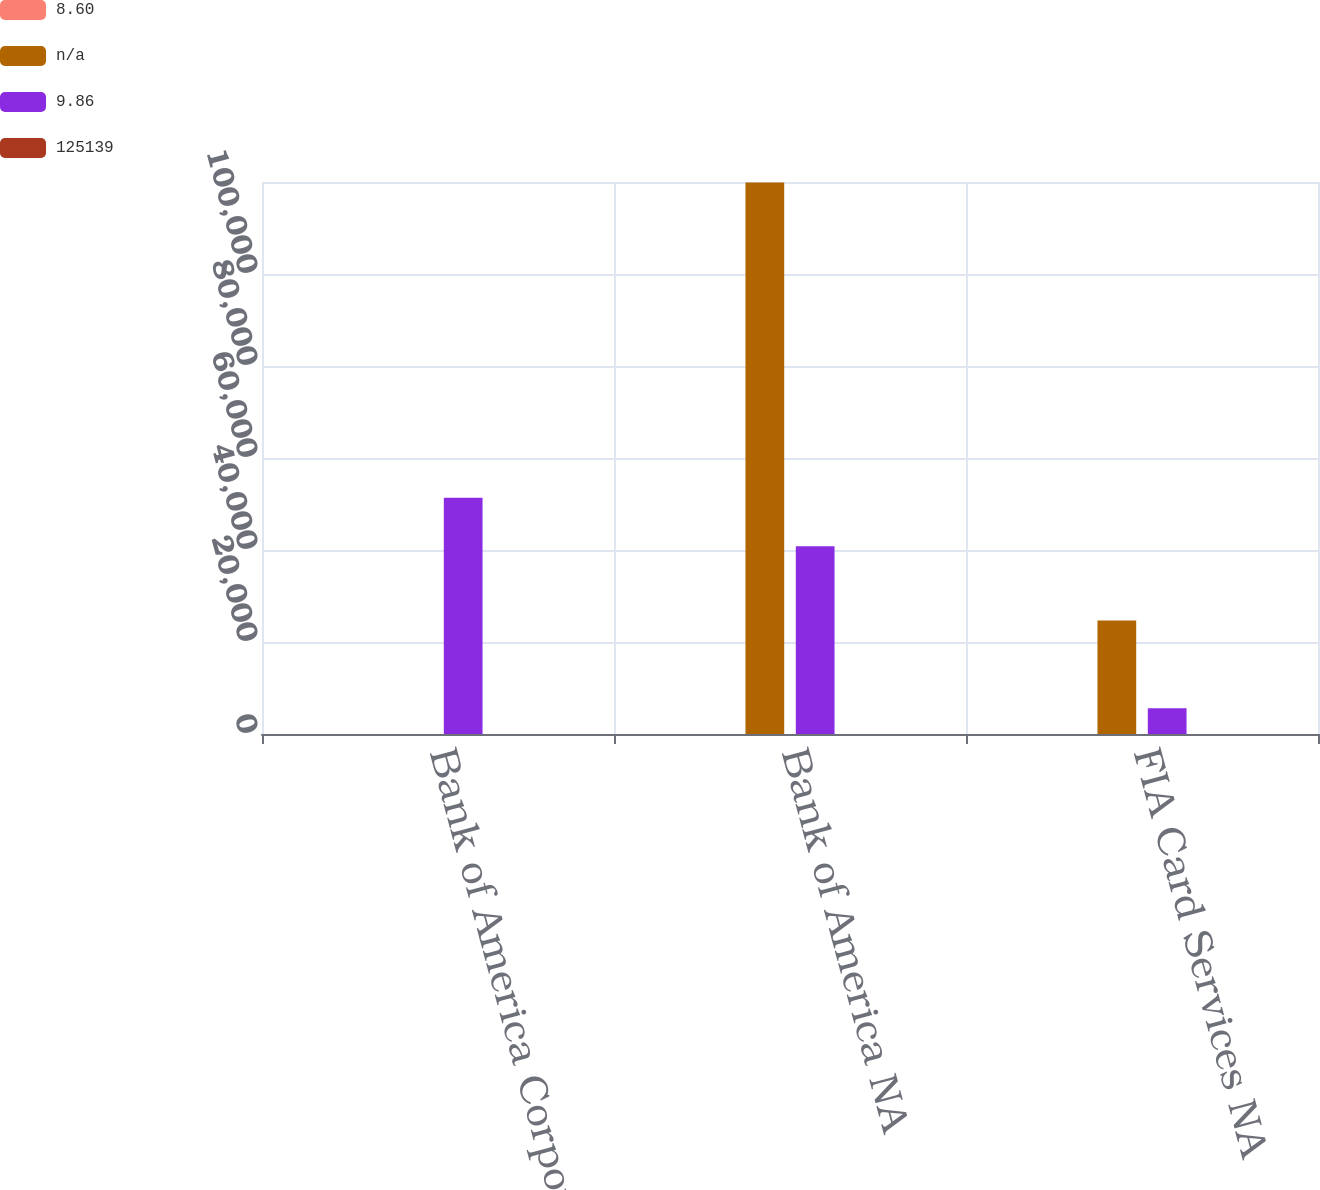Convert chart. <chart><loc_0><loc_0><loc_500><loc_500><stacked_bar_chart><ecel><fcel>Bank of America Corporation<fcel>Bank of America NA<fcel>FIA Card Services NA<nl><fcel>8.6<fcel>12.4<fcel>11.74<fcel>17.63<nl><fcel>nan<fcel>17.63<fcel>119881<fcel>24660<nl><fcel>9.86<fcel>51379<fcel>40830<fcel>5596<nl><fcel>125139<fcel>11.24<fcel>10.78<fcel>15.3<nl></chart> 